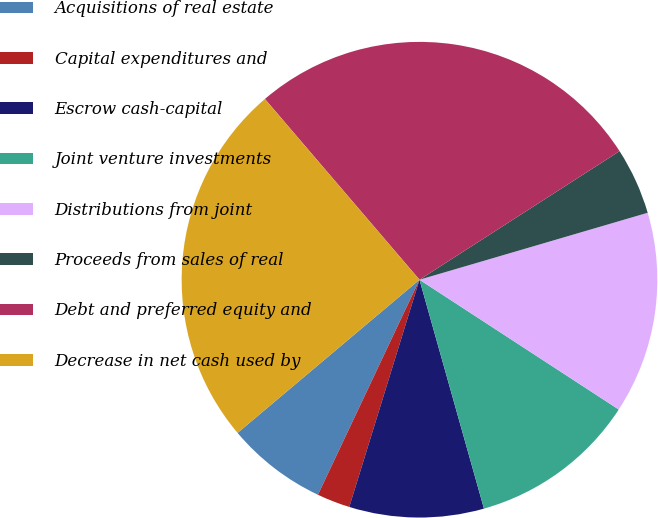<chart> <loc_0><loc_0><loc_500><loc_500><pie_chart><fcel>Acquisitions of real estate<fcel>Capital expenditures and<fcel>Escrow cash-capital<fcel>Joint venture investments<fcel>Distributions from joint<fcel>Proceeds from sales of real<fcel>Debt and preferred equity and<fcel>Decrease in net cash used by<nl><fcel>6.84%<fcel>2.25%<fcel>9.14%<fcel>11.44%<fcel>13.73%<fcel>4.55%<fcel>27.17%<fcel>24.88%<nl></chart> 